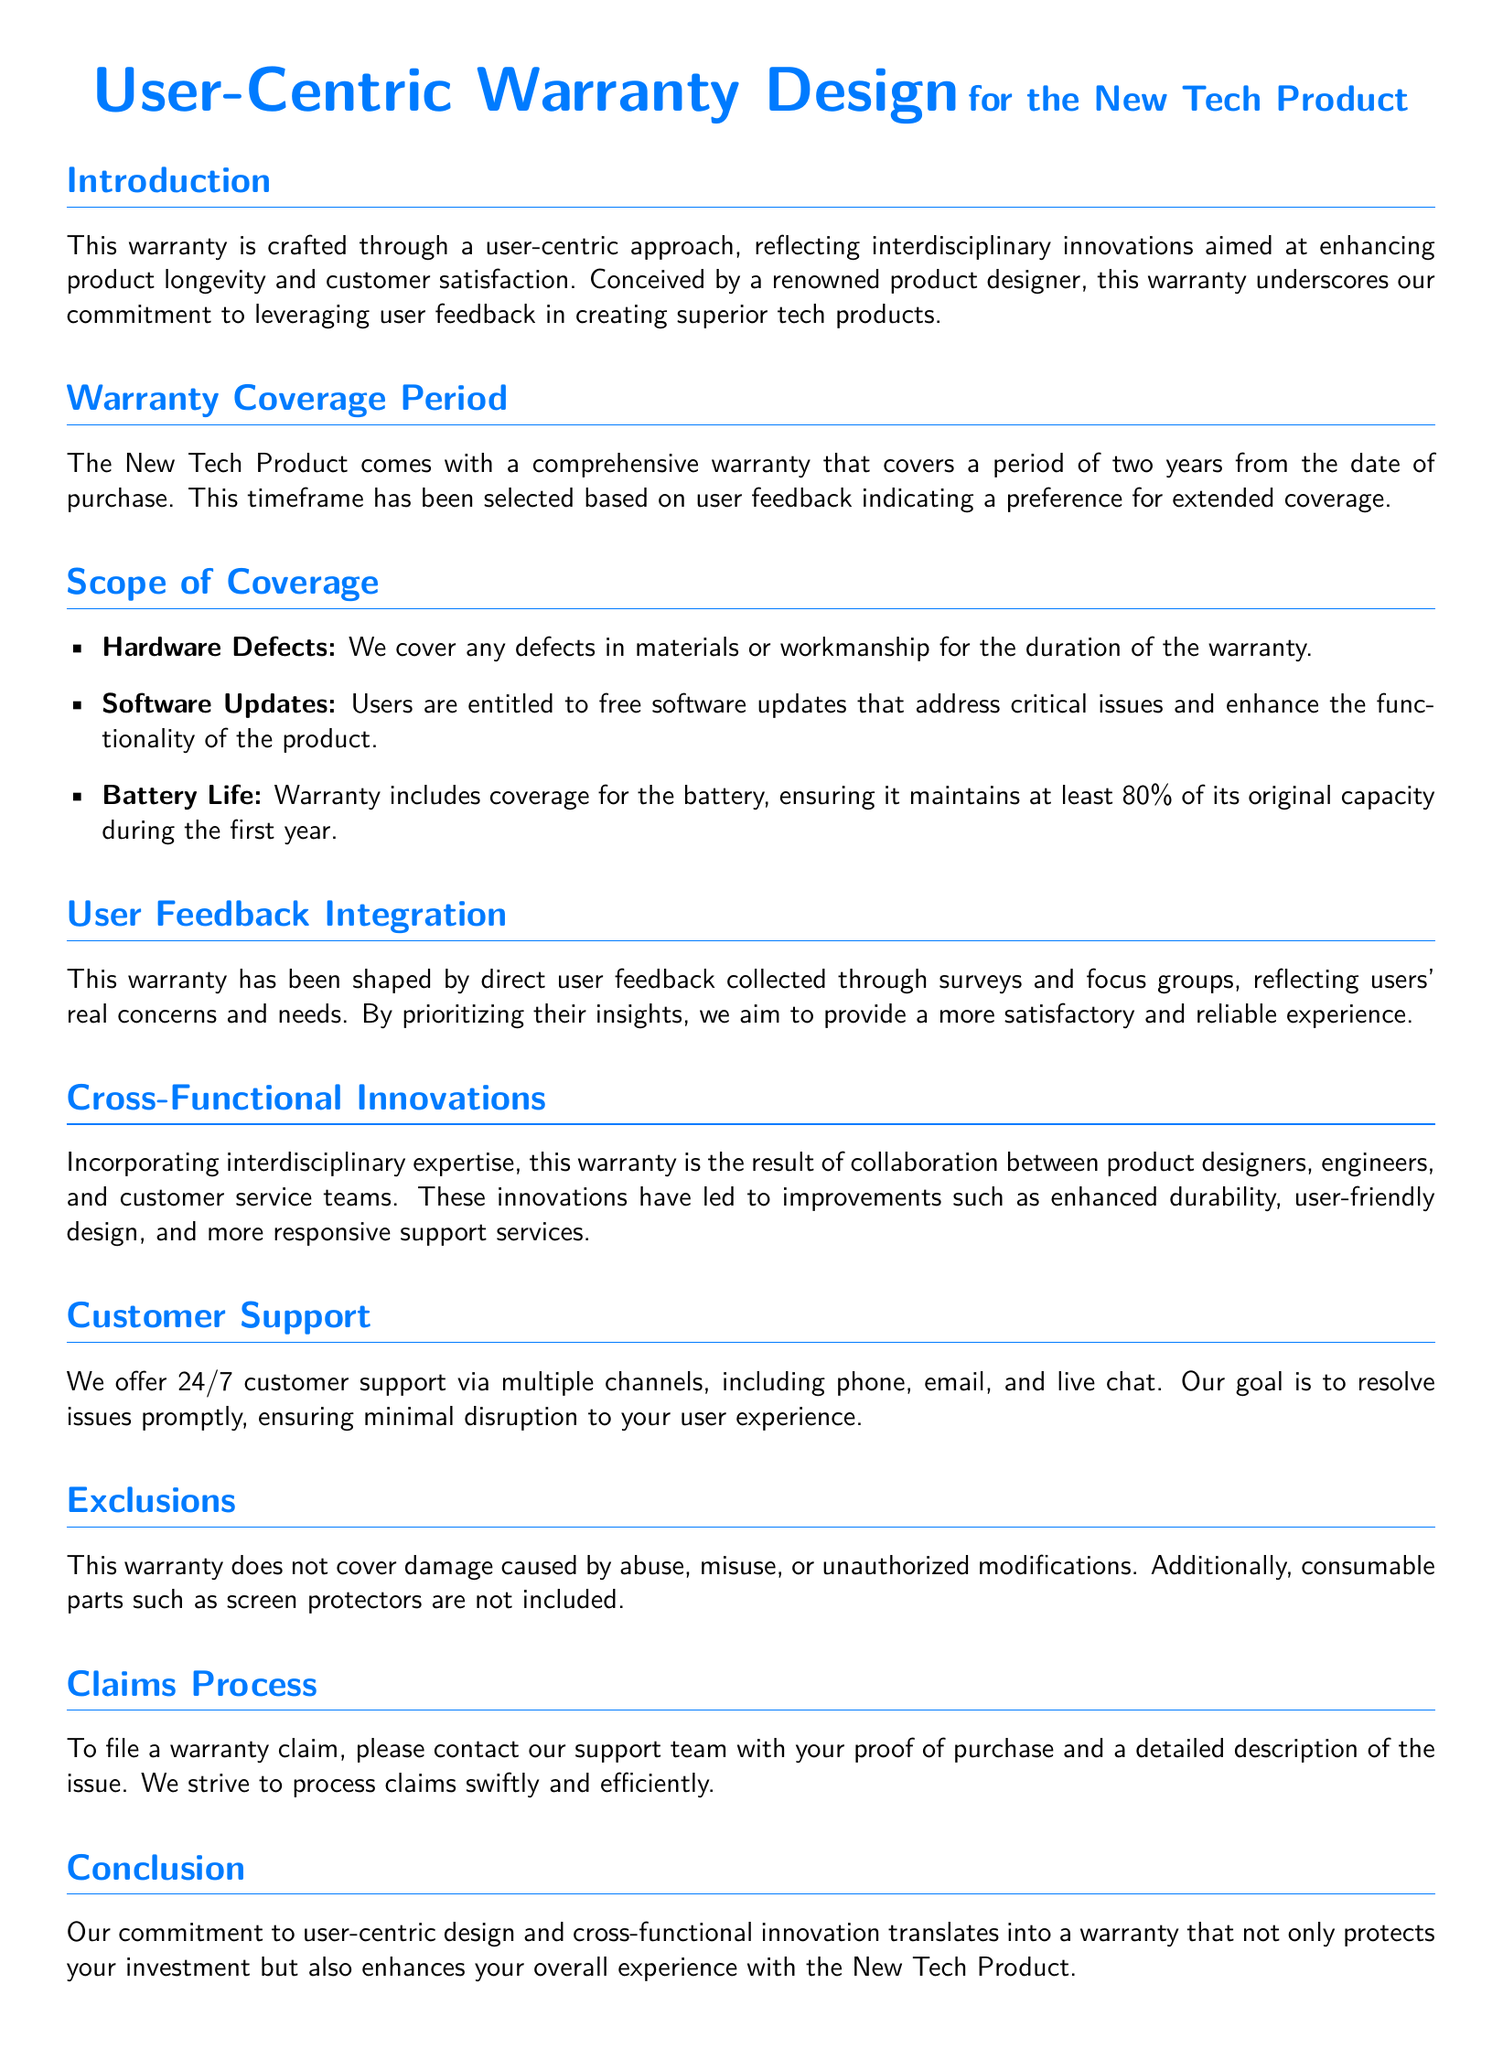What is the warranty coverage period? The warranty coverage period is explicitly stated in the document, which mentions a duration of two years from the date of purchase.
Answer: two years What does the warranty cover? The document lists specific areas of coverage under the warranty provisions, including hardware defects, software updates, and battery life.
Answer: hardware defects, software updates, battery life What percentage of original battery capacity is guaranteed in the first year? The document specifies that the warranty includes coverage for the battery, ensuring it maintains at least a certain percentage of its original capacity during the first year.
Answer: 80% How is user feedback integrated into this warranty? The document states that the warranty has been shaped by direct user feedback collected through specific methods, indicating the importance of user input in its design.
Answer: surveys and focus groups What type of support is offered to customers? The document outlines the types of support available to users, specifying how and when they can reach out for assistance.
Answer: 24/7 customer support What excludes the warranty coverage? The document explicitly mentions certain circumstances and items that are not covered under the warranty, including damage caused by specific actions.
Answer: abuse, misuse, unauthorized modifications Which teams collaborated to create this warranty? The document highlights the interdisciplinary approach taken in the design of the warranty, noting the types of professionals involved in its development.
Answer: product designers, engineers, customer service teams What is required to file a warranty claim? The document specifies the necessary steps one must take to begin the claims process for warranty issues.
Answer: proof of purchase and a detailed description of the issue 